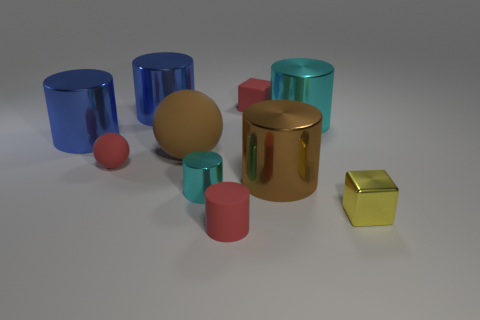What can you infer about the lighting and texture of the surfaces in the picture? The lighting in the image is soft and diffused, casting gentle shadows and highlights on the objects, which suggests an indoor setting with ambient lighting. The cylinders' surfaces vary, with matte finishes absorbing light and metallic ones reflecting it, contributing to a sense of depth and texture in the composition. 